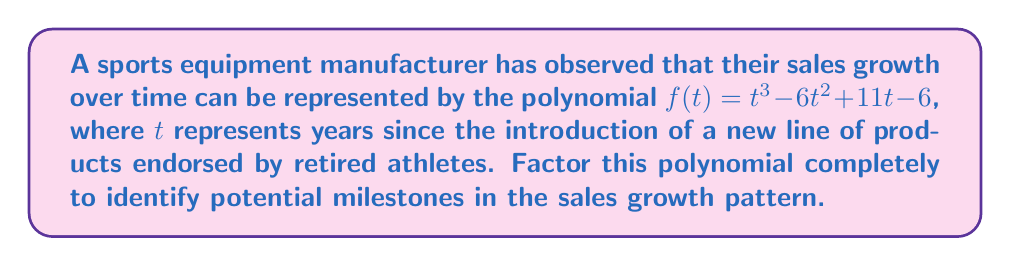Help me with this question. To factor the polynomial $f(t) = t^3 - 6t^2 + 11t - 6$, we'll follow these steps:

1) First, let's check if there's a common factor. In this case, there isn't.

2) Next, we'll try to guess one root. Let's consider the factors of the constant term (-6): ±1, ±2, ±3, ±6. 
   Testing these, we find that $f(1) = 1 - 6 + 11 - 6 = 0$, so $(t-1)$ is a factor.

3) We can now use polynomial long division to divide $f(t)$ by $(t-1)$:

   $$t^3 - 6t^2 + 11t - 6 = (t-1)(t^2 - 5t + 6)$$

4) Now we need to factor the quadratic term $t^2 - 5t + 6$. We can do this by finding two numbers that multiply to give 6 and add to give -5. These numbers are -2 and -3.

5) Therefore, $t^2 - 5t + 6 = (t-2)(t-3)$

6) Combining all factors, we get:

   $$f(t) = (t-1)(t-2)(t-3)$$

This factorization reveals that the sales growth function has roots at $t=1$, $t=2$, and $t=3$, which could represent significant milestones in the product lifecycle.
Answer: $(t-1)(t-2)(t-3)$ 